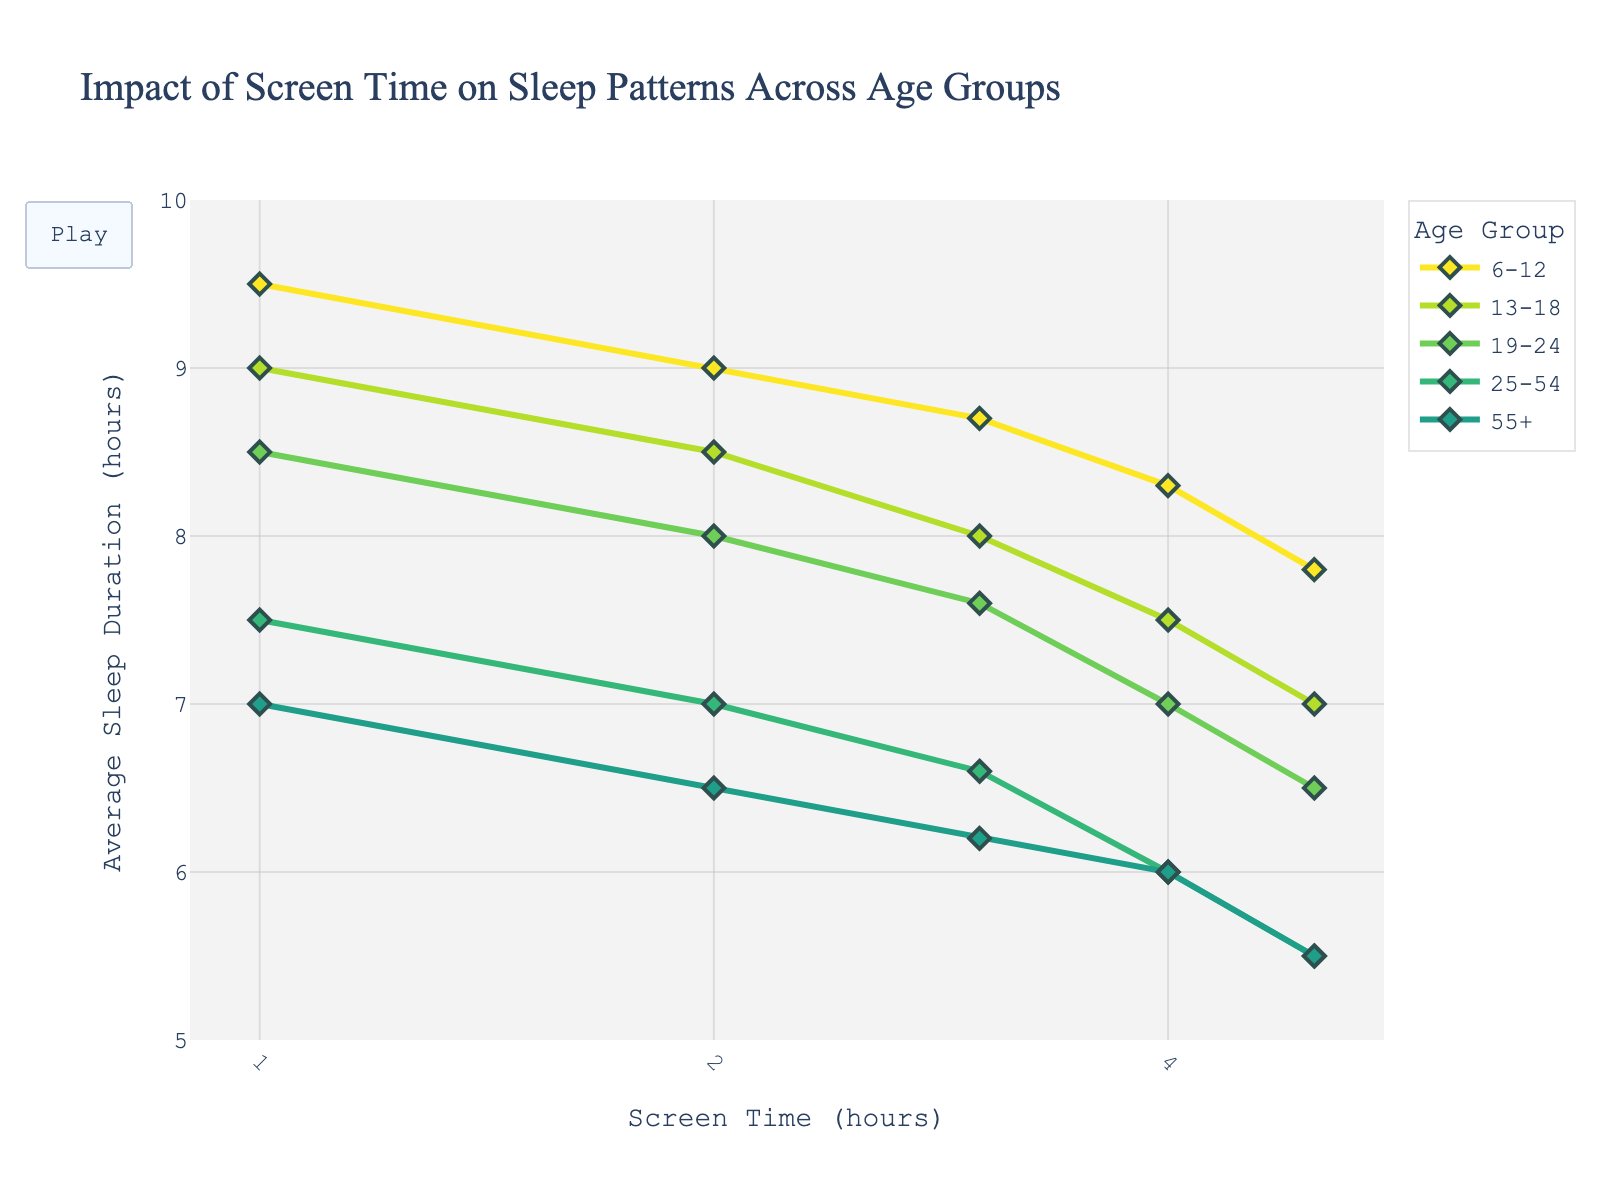what is the title of the plot? The title is displayed at the top of the figure in a prominent font.
Answer: Impact of Screen Time on Sleep Patterns Across Different Age Groups How is the x-axis scaled, and what values can you see? The x-axis is scaled logarithmically, and the values visible include ticks at 1, 2, 4, and 8.
Answer: logarithmic with ticks at 1, 2, 4, 8 How does the average sleep duration change with increased screen time for the 6-12 age group? The 6-12 age group shows a decreasing trend in average sleep duration as screen time increases from 9.5 hours at 1 hour of screen time to 7.8 hours at 5 hours of screen time.
Answer: decreases Which age group shows the least change in average sleep duration with increasing screen time? By comparing the slopes of the lines for each age group, the 55+ age group shows the least steep decline in average sleep duration with increased screen time.
Answer: 55+ What is the difference in average sleep duration between the 6-12 age group and the 25-54 age group at 2 hours of screen time? The 6-12 age group has an average sleep duration of 9 hours, and the 25-54 age group has 7 hours at 2 hours of screen time, resulting in a difference of 2 hours.
Answer: 2 hours Which age group experiences the highest average sleep duration at 1 hour of screen time? By examining the plot, the 6-12 age group experiences the highest average sleep duration of 9.5 hours at 1 hour of screen time.
Answer: 6-12 How does the average sleep duration for the 19-24 age group compare at 3 and 5 hours of screen time? The average sleep duration for the 19-24 age group is 7.6 hours at 3 hours of screen time and 6.5 hours at 5 hours of screen time, showing a decrease of 1.1 hours.
Answer: decreases by 1.1 hours At what screen time do the 13-18 and 25-54 age groups have the same average sleep duration? Both age groups have the same average sleep duration of 7.5 hours at 1 hour of screen time.
Answer: 1 hour What trend can be observed in the sleep duration across different age groups as screen time increases from 1 to 5 hours? The general trend shows that average sleep duration decreases with increasing screen time across all age groups.
Answer: decreases across all age groups 